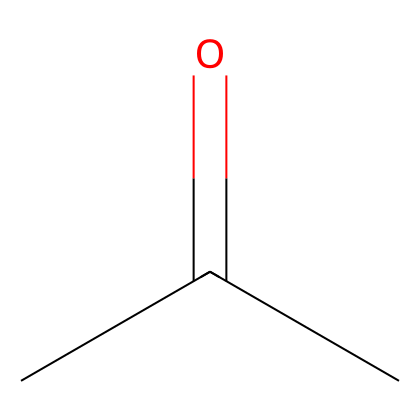What is the molecular formula of acetone? The SMILES representation shows three carbon atoms (C), six hydrogen atoms (H), and one oxygen atom (O) with the structure. The formula can be deduced as C3H6O.
Answer: C3H6O How many hydrogen atoms are present in acetone? By analyzing the structure, there are six hydrogen atoms bonded to the three carbon atoms and the functional group, indicating the total number of hydrogens.
Answer: six What type of functional group is present in acetone? The carbonyl group (C=O) is evident in the structure, which is characteristic of ketones, indicating that acetone is a ketone.
Answer: carbonyl How many bonds does the carbon atom in the carbonyl group form? The carbon of the carbonyl (C=O) is double-bonded to oxygen and single-bonded to two other carbon atoms, accounting for a total of three bonds.
Answer: three What is the hybridization of the carbon atoms in acetone? In the structure, the carbon atoms involved in the carbonyl group (C=O) exhibit sp2 hybridization due to the presence of a double bond, while the other carbon atoms exhibit sp3 hybridization.
Answer: sp2 and sp3 Does acetone have any stereocenters? Looking at the structure, no carbon atom is attached to four different substituents, indicating that it does not possess any stereocenters.
Answer: no 